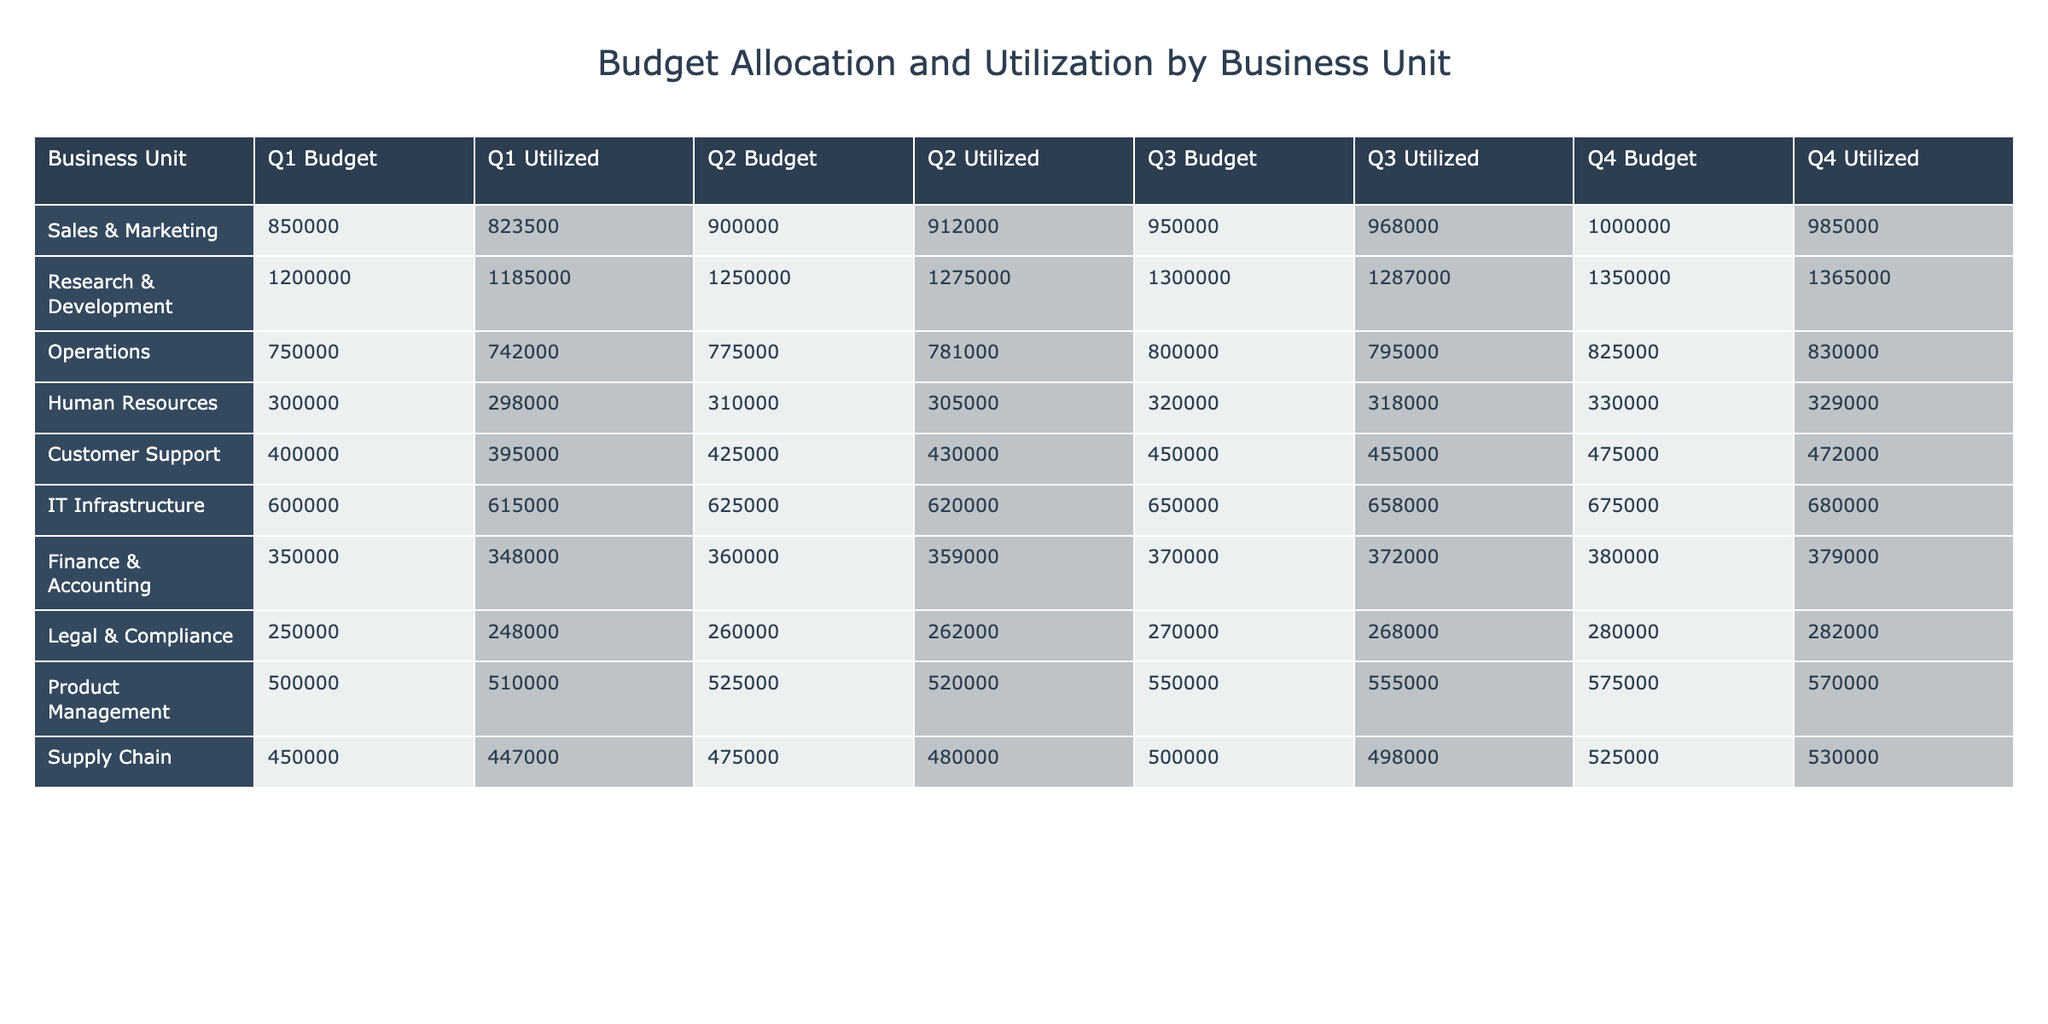What is the total budget allocated to the Sales & Marketing unit for the fiscal year? To get the total budget allocated to Sales & Marketing, we add the budgets from each quarter: 850,000 (Q1) + 900,000 (Q2) + 950,000 (Q3) + 1,000,000 (Q4) = 3,700,000.
Answer: 3,700,000 Which unit had the highest budget utilization in Q3? In Q3, the budget utilization values for each unit need to be compared: Sales & Marketing (968,000), R&D (1,287,000), Operations (795,000), HR (318,000), Customer Support (455,000), IT (658,000), Finance (372,000), Legal (268,000), Product Management (555,000), and Supply Chain (498,000). R&D has the highest utilization of 1,287,000.
Answer: R&D What is the total amount utilized by the Human Resources unit for the fiscal year? To find the total utilized amount for Human Resources, sum the utilized values from each quarter: 298,000 (Q1) + 305,000 (Q2) + 318,000 (Q3) + 329,000 (Q4) = 1,250,000.
Answer: 1,250,000 Did the Operations unit exceed their budget in Q4? The budget for Operations in Q4 was 825,000, and the utilization was 830,000. To check if they exceeded their budget, compare the utilized amount to the budget: 830,000 is greater than 825,000, indicating they did exceed their budget.
Answer: Yes What is the difference in budget allocation between Research & Development and IT Infrastructure in Q2? The budget allocated for R&D in Q2 is 1,250,000, while IT Infrastructure received 625,000. To find the difference, subtract the IT budget from the R&D budget: 1,250,000 - 625,000 = 625,000.
Answer: 625,000 Which business unit had the lowest budget utilization in Q1? In Q1, the budget utilization figures for each unit are: Sales & Marketing (823,500), R&D (1,185,000), Operations (742,000), HR (298,000), Customer Support (395,000), IT (615,000), Finance (348,000), Legal (248,000), Product Management (510,000), and Supply Chain (447,000). The lowest utilizations are compared and Legal & Compliance had the lowest at 248,000.
Answer: Legal & Compliance What is the average budget allocation for the Customer Support unit over the four quarters? The budget allocations for Customer Support are: 400,000 (Q1), 425,000 (Q2), 450,000 (Q3), and 475,000 (Q4). To find the average, we first sum these amounts: 400,000 + 425,000 + 450,000 + 475,000 = 1,750,000. Then, divide by the number of quarters (4): 1,750,000 / 4 = 437,500.
Answer: 437,500 How much more budget was allocated to Supply Chain than to Legal & Compliance over the entire fiscal year? First, calculate the total budget for each unit: Supply Chain (450,000 + 475,000 + 500,000 + 525,000 = 1,950,000) and Legal & Compliance (250,000 + 260,000 + 270,000 + 280,000 = 1,060,000). Then, subtract the total for Legal from Supply Chain: 1,950,000 - 1,060,000 = 890,000.
Answer: 890,000 Was the total budget utilized across all quarters greater than the total budget allocated for all units? First, calculate the total budget allocated by summing the budgets for each unit across quarters. Then, sum the utilized amounts for each unit. For the allocated budgets: 3,700,000 (Sales) + 5,000,000 (R&D) + 3,100,000 (Operations) + 1,260,000 (HR) + 1,750,000 (CS) + 2,550,000 (IT) + 1,480,000 (Finance) + 1,060,000 (Legal) + 2,250,000 (PM) + 1,950,000 (Supply Chain) = 25,000,000. For utilized amounts: 3,445,500. The utilized amount is less than the allocated, so the answer is no.
Answer: No Which quarter saw the largest increase in budget utilization for Product Management compared to the previous quarter? The utilized amounts for Product Management are: 510,000 (Q1), 520,000 (Q2), 555,000 (Q3), and 570,000 (Q4). The increases between quarters are: Q1 to Q2 (+10,000), Q2 to Q3 (+35,000), and Q3 to Q4 (+15,000). The largest increase occurs from Q2 to Q3.
Answer: Q2 to Q3 